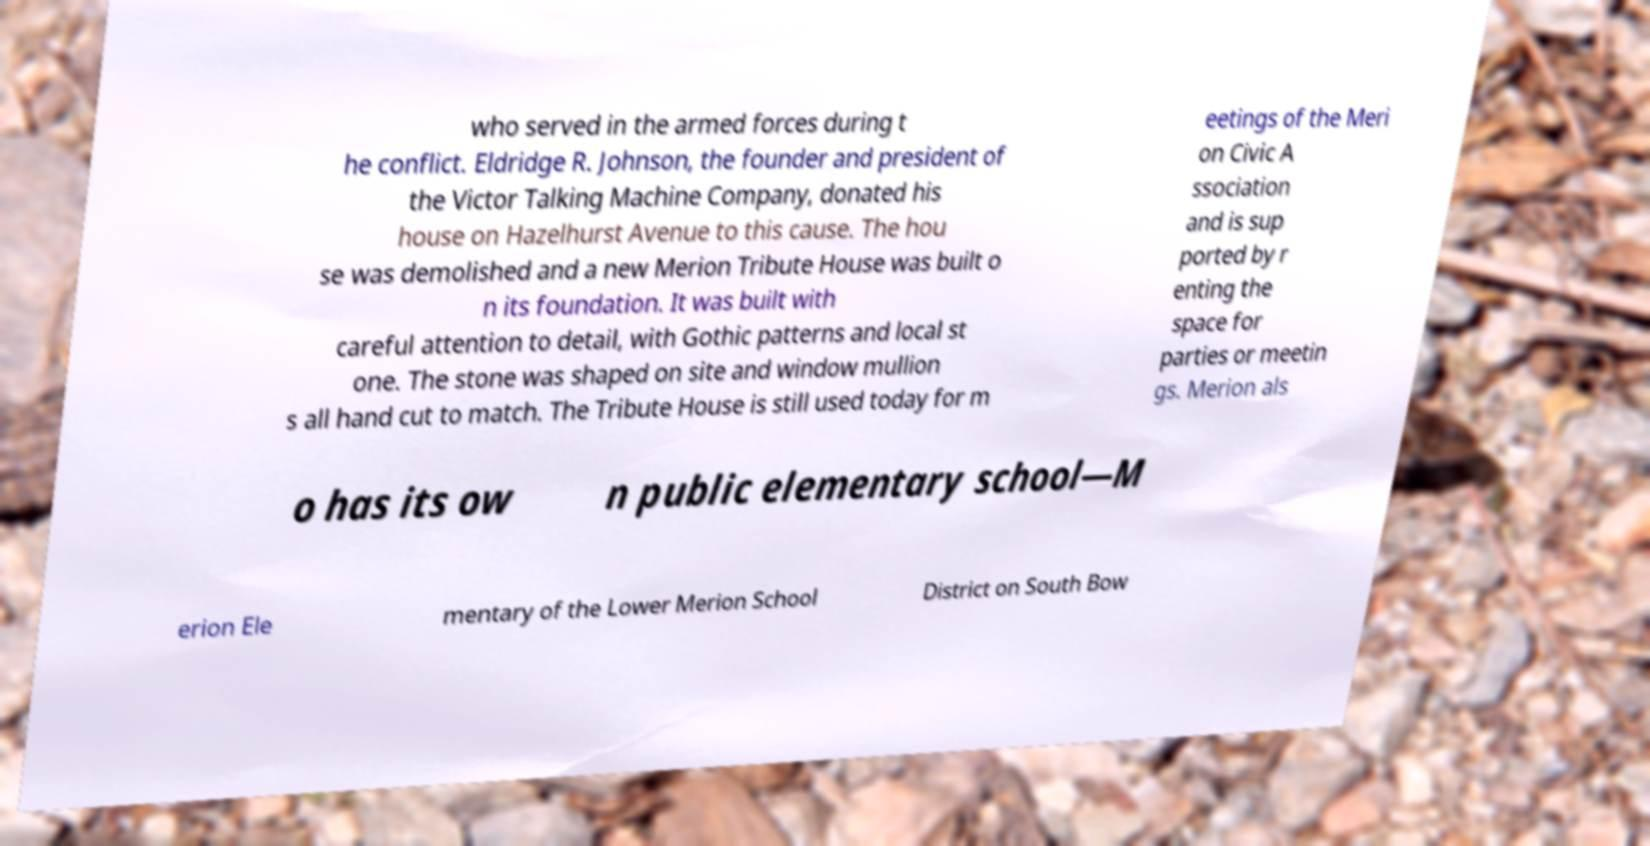What messages or text are displayed in this image? I need them in a readable, typed format. who served in the armed forces during t he conflict. Eldridge R. Johnson, the founder and president of the Victor Talking Machine Company, donated his house on Hazelhurst Avenue to this cause. The hou se was demolished and a new Merion Tribute House was built o n its foundation. It was built with careful attention to detail, with Gothic patterns and local st one. The stone was shaped on site and window mullion s all hand cut to match. The Tribute House is still used today for m eetings of the Meri on Civic A ssociation and is sup ported by r enting the space for parties or meetin gs. Merion als o has its ow n public elementary school—M erion Ele mentary of the Lower Merion School District on South Bow 